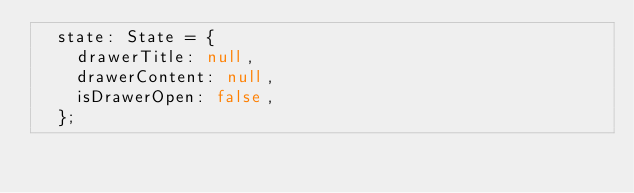Convert code to text. <code><loc_0><loc_0><loc_500><loc_500><_TypeScript_>  state: State = {
    drawerTitle: null,
    drawerContent: null,
    isDrawerOpen: false,
  };</code> 